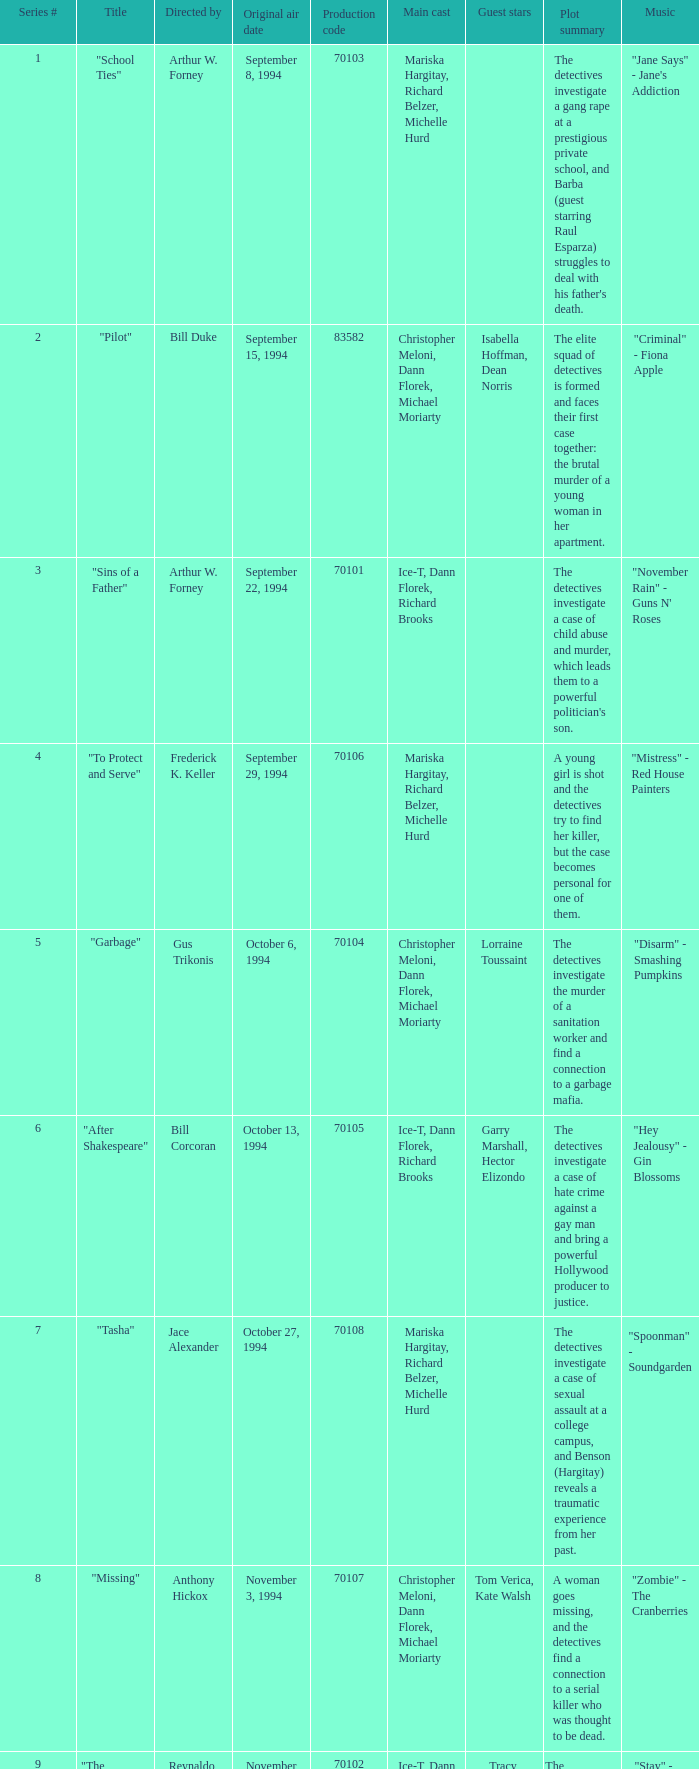For the "Downtown Girl" episode, what was the original air date? May 4, 1995. 